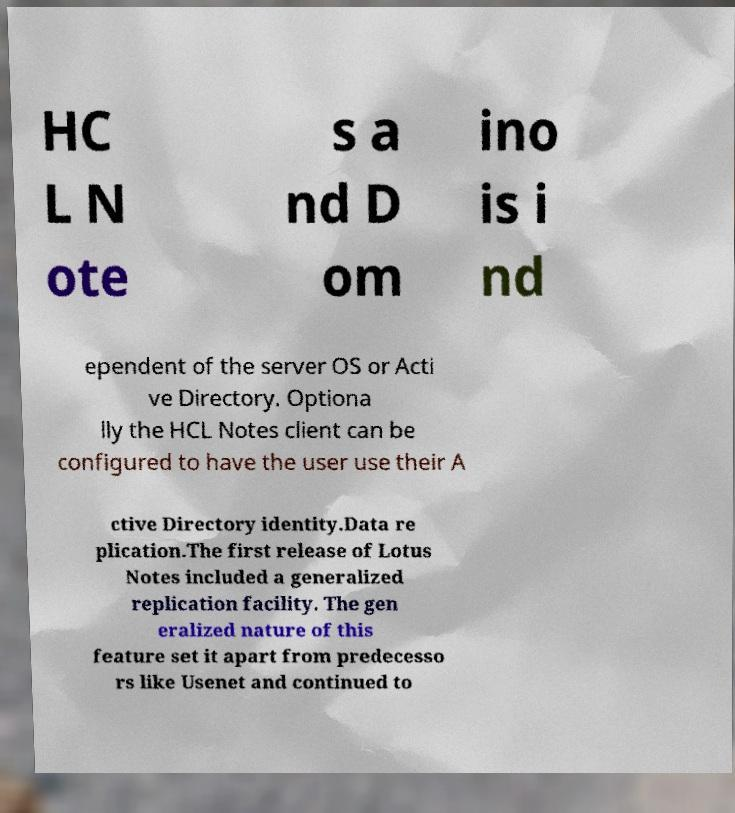Can you accurately transcribe the text from the provided image for me? HC L N ote s a nd D om ino is i nd ependent of the server OS or Acti ve Directory. Optiona lly the HCL Notes client can be configured to have the user use their A ctive Directory identity.Data re plication.The first release of Lotus Notes included a generalized replication facility. The gen eralized nature of this feature set it apart from predecesso rs like Usenet and continued to 